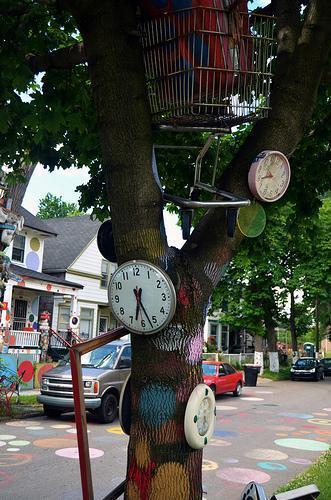How many trees are in this picture?
Give a very brief answer. 1. 